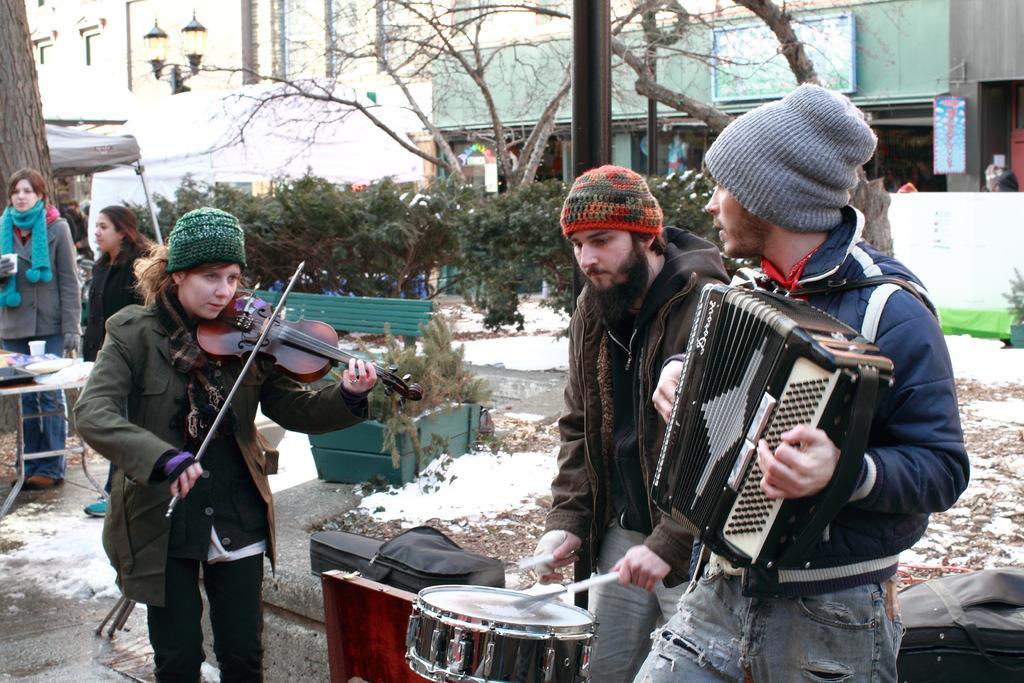Please provide a concise description of this image. people are standing on the roadside. there are 3 people at the front. the person at the left is playing violin. the person at the center is playing drums. the person at the right is playing harmonium which is black in color. they are wearing woolen caps. at the left there are 2 people standing. behind them there is green bench, trees, buildings. 